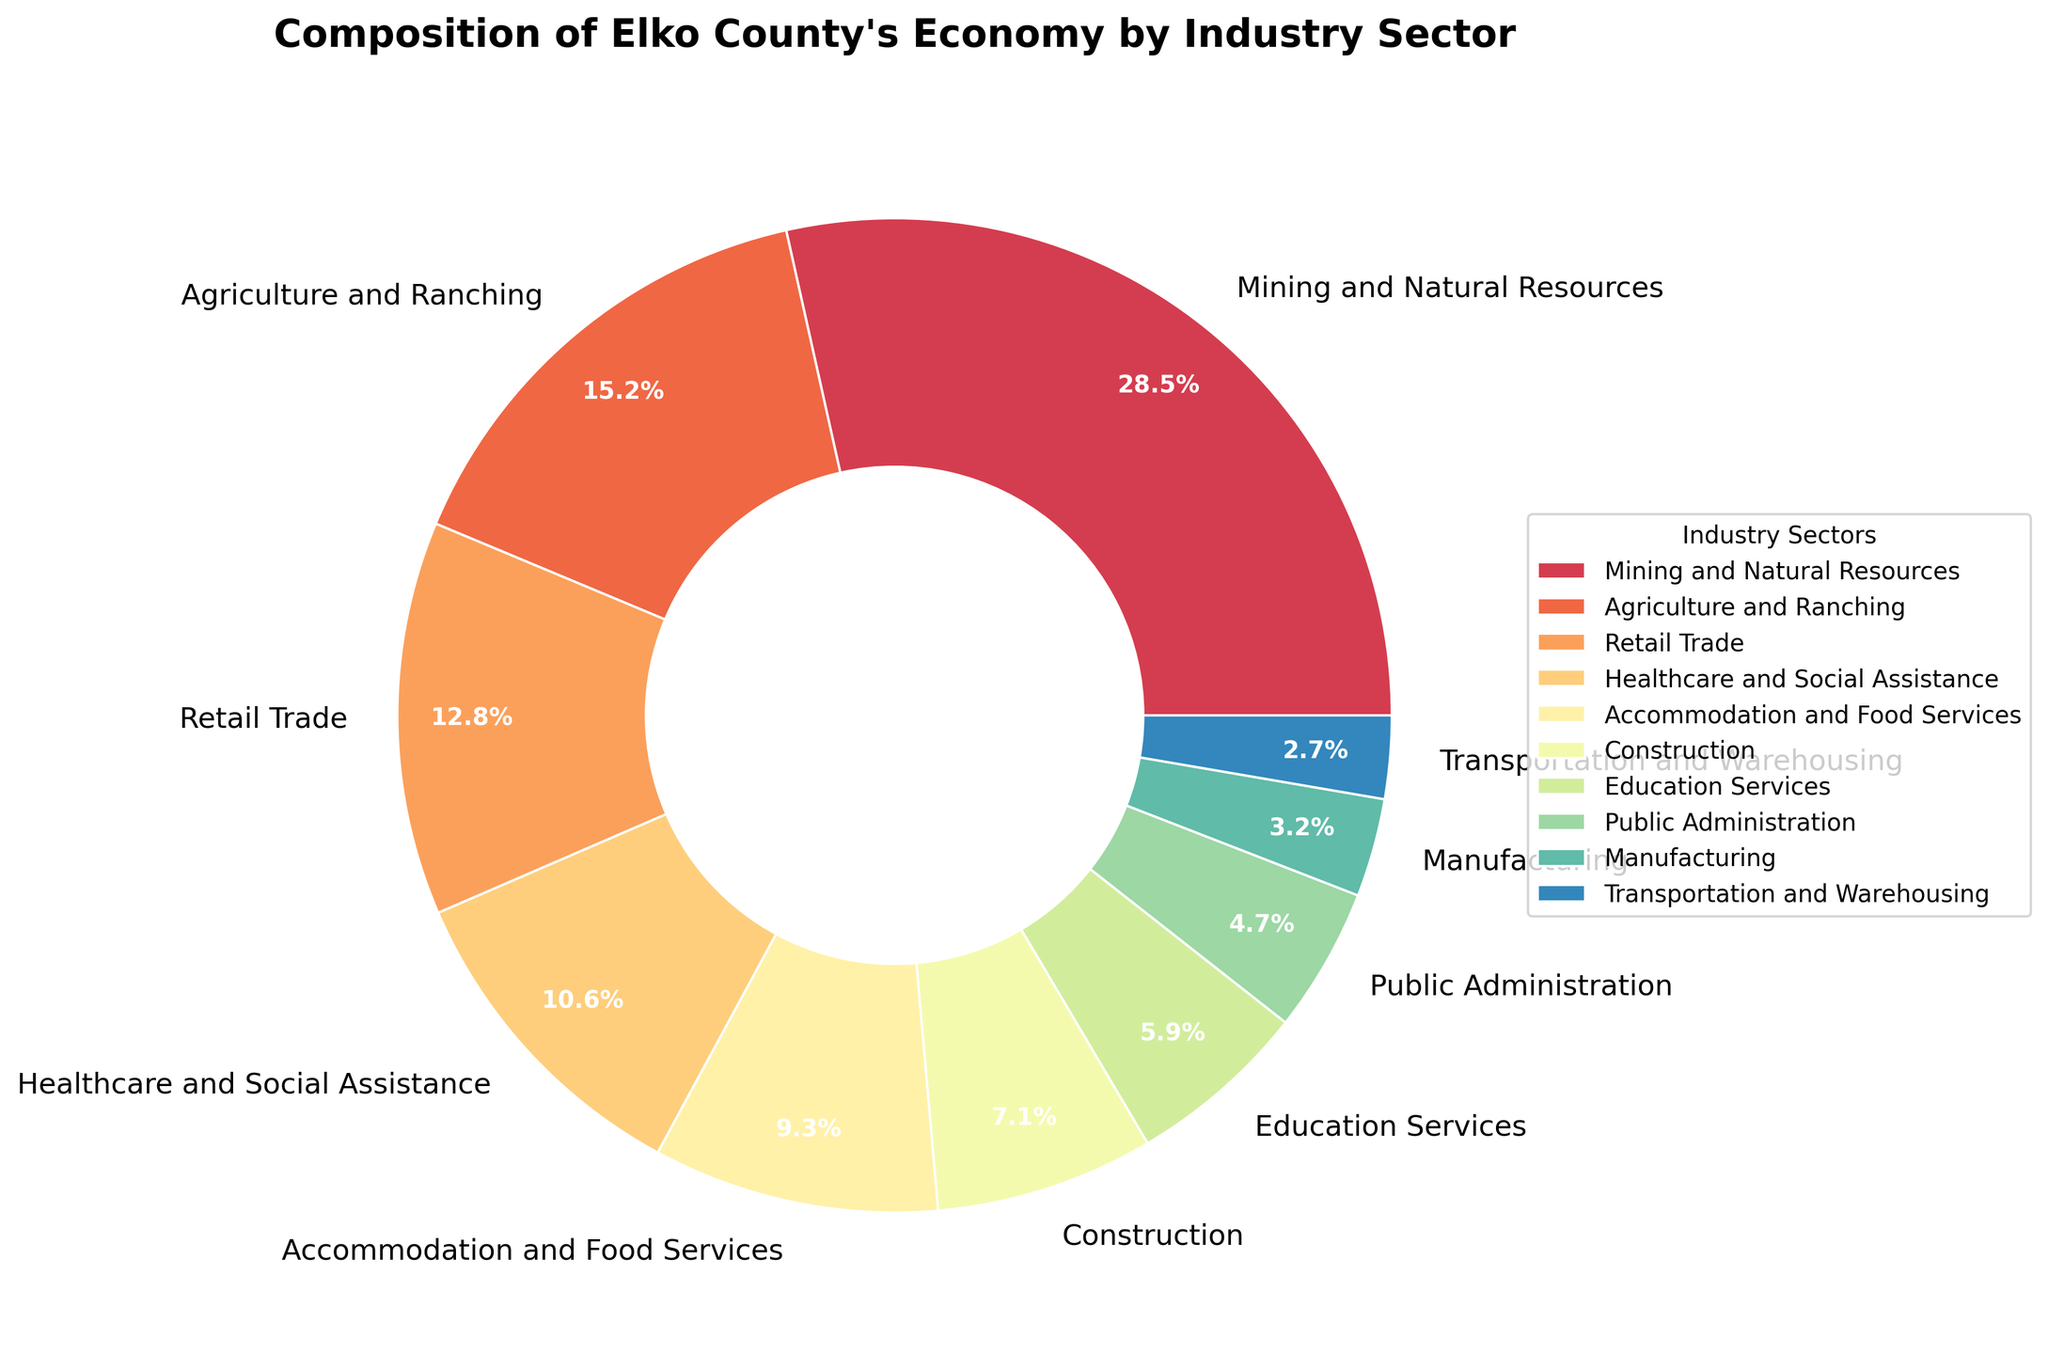What industry sector has the largest contribution to Elko County's economy? The industry sector with the largest percentage value in the pie chart is the one with the largest contribution to Elko County's economy. In this case, it is the "Mining and Natural Resources" sector.
Answer: Mining and Natural Resources What is the combined contribution of Agriculture and Ranching and Healthcare and Social Assistance sectors? To find the combined contribution, sum the percentages of the Agriculture and Ranching sector (15.2%) and the Healthcare and Social Assistance sector (10.6%). 15.2% + 10.6% = 25.8%.
Answer: 25.8% Is the contribution of the Education Services sector greater than that of the Public Administration sector? Compare the percentage values of both sectors. The Education Services sector has 5.9%, and the Public Administration sector has 4.7%. Since 5.9% is greater than 4.7%, the answer is yes.
Answer: Yes Which sector has a smaller contribution to the economy: Manufacturing or Construction? Compare the percentage values of the Manufacturing sector (3.2%) and the Construction sector (7.1%). Since 3.2% is less than 7.1%, Manufacturing has the smaller contribution.
Answer: Manufacturing What is the percentage difference between the Retail Trade and the Accommodation and Food Services sectors? Subtract the percentage of Accommodation and Food Services (9.3%) from the percentage of Retail Trade (12.8%). 12.8% - 9.3% = 3.5%.
Answer: 3.5% How many sectors contribute less than 10% each to Elko County's economy? Count the number of sectors in the pie chart that have a percentage value less than 10%. The sectors are Construction (7.1%), Education Services (5.9%), Public Administration (4.7%), Manufacturing (3.2%), and Transportation and Warehousing (2.7%), which totals 5 sectors.
Answer: 5 Which sector has a darker shade in the pie chart, Mining and Natural Resources or Education Services? Visually compare the color shades of the segments. Mining and Natural Resources has a darker shade compared to Education Services in the pie chart.
Answer: Mining and Natural Resources 